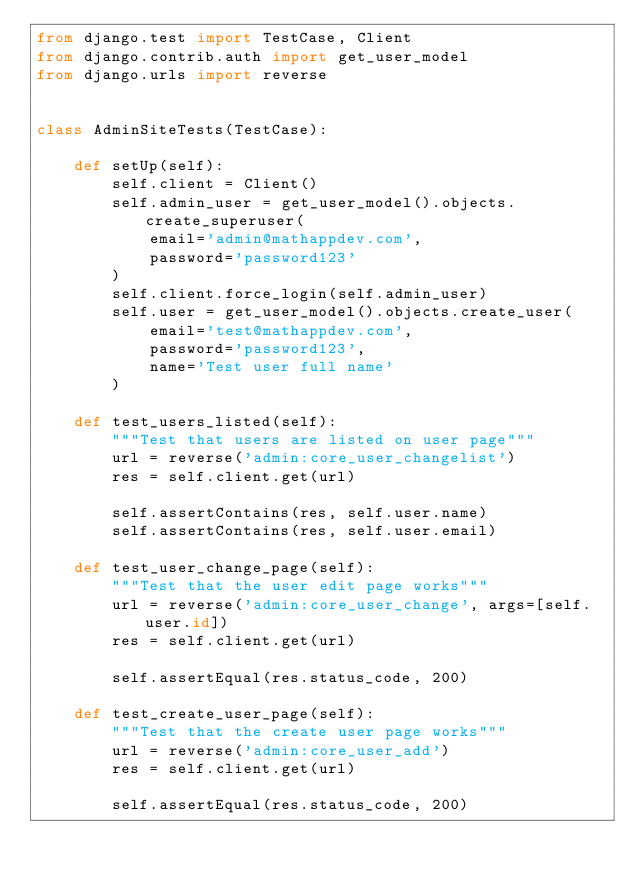Convert code to text. <code><loc_0><loc_0><loc_500><loc_500><_Python_>from django.test import TestCase, Client
from django.contrib.auth import get_user_model
from django.urls import reverse


class AdminSiteTests(TestCase):

    def setUp(self):
        self.client = Client()
        self.admin_user = get_user_model().objects.create_superuser(
            email='admin@mathappdev.com',
            password='password123'
        )
        self.client.force_login(self.admin_user)
        self.user = get_user_model().objects.create_user(
            email='test@mathappdev.com',
            password='password123',
            name='Test user full name'
        )

    def test_users_listed(self):
        """Test that users are listed on user page"""
        url = reverse('admin:core_user_changelist')
        res = self.client.get(url)

        self.assertContains(res, self.user.name)
        self.assertContains(res, self.user.email)

    def test_user_change_page(self):
        """Test that the user edit page works"""
        url = reverse('admin:core_user_change', args=[self.user.id])
        res = self.client.get(url)

        self.assertEqual(res.status_code, 200)

    def test_create_user_page(self):
        """Test that the create user page works"""
        url = reverse('admin:core_user_add')
        res = self.client.get(url)

        self.assertEqual(res.status_code, 200)
</code> 